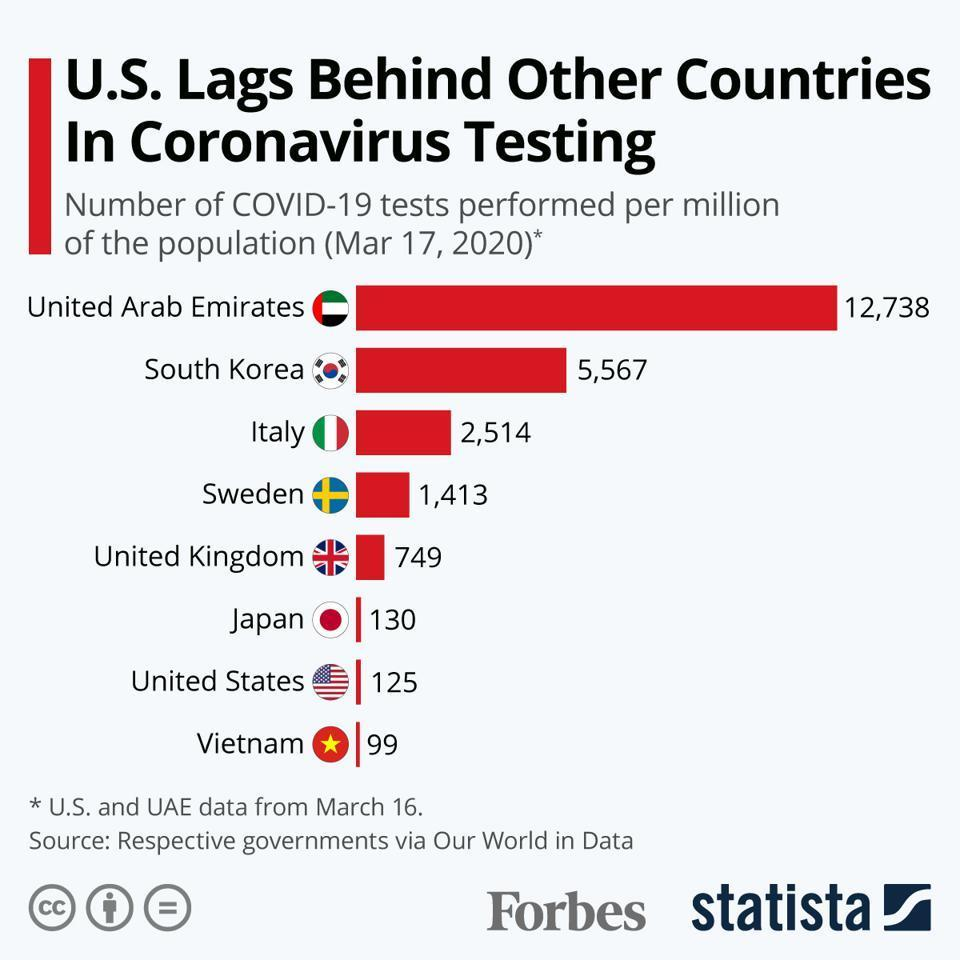Which country has performed the lowest number of COVID-19 tests per million population among the given countries as of Mar 17, 2020?
Answer the question with a short phrase. Vietnam What is the number of COVID-19 tests performed per million of the population in UK as of Mar 17, 2020? 749 What is the number of COVID-19 tests performed per million of the population in Japan as of Mar 17, 2020? 130 Which country has performed the second highest number of COVID-19 tests per million population among the given countries as of Mar 17, 2020? South Korea What is the number of COVID-19 tests performed per million of the population in Italy as of Mar 17, 2020? 2,514 Which country has conducted the highest number of COVID-19 tests per million population among the given countries as of Mar 17, 2020? UAE 